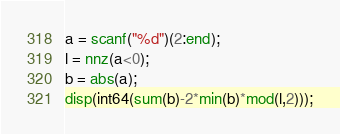Convert code to text. <code><loc_0><loc_0><loc_500><loc_500><_Octave_>a = scanf("%d")(2:end);
l = nnz(a<0);
b = abs(a);
disp(int64(sum(b)-2*min(b)*mod(l,2)));
</code> 